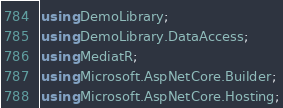<code> <loc_0><loc_0><loc_500><loc_500><_C#_>using DemoLibrary;
using DemoLibrary.DataAccess;
using MediatR;
using Microsoft.AspNetCore.Builder;
using Microsoft.AspNetCore.Hosting;</code> 